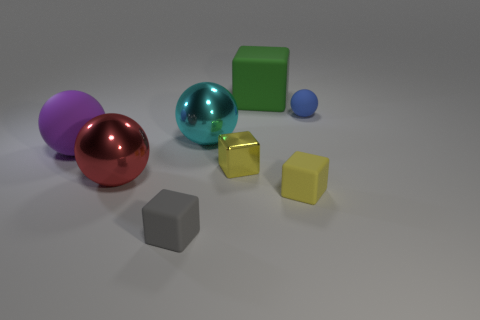Add 2 gray rubber cylinders. How many objects exist? 10 Subtract all yellow shiny cubes. How many cubes are left? 3 Subtract all gray cubes. How many cubes are left? 3 Subtract 3 spheres. How many spheres are left? 1 Subtract all brown cylinders. How many yellow blocks are left? 2 Subtract all big cyan rubber cylinders. Subtract all yellow shiny objects. How many objects are left? 7 Add 7 big red spheres. How many big red spheres are left? 8 Add 3 tiny green cubes. How many tiny green cubes exist? 3 Subtract 0 brown spheres. How many objects are left? 8 Subtract all brown cubes. Subtract all yellow cylinders. How many cubes are left? 4 